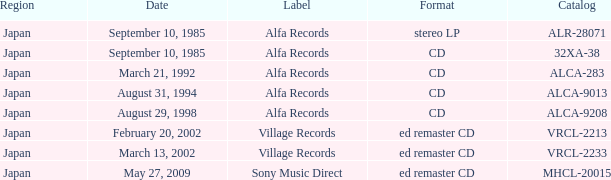Which Label was cataloged as alca-9013? Alfa Records. Parse the full table. {'header': ['Region', 'Date', 'Label', 'Format', 'Catalog'], 'rows': [['Japan', 'September 10, 1985', 'Alfa Records', 'stereo LP', 'ALR-28071'], ['Japan', 'September 10, 1985', 'Alfa Records', 'CD', '32XA-38'], ['Japan', 'March 21, 1992', 'Alfa Records', 'CD', 'ALCA-283'], ['Japan', 'August 31, 1994', 'Alfa Records', 'CD', 'ALCA-9013'], ['Japan', 'August 29, 1998', 'Alfa Records', 'CD', 'ALCA-9208'], ['Japan', 'February 20, 2002', 'Village Records', 'ed remaster CD', 'VRCL-2213'], ['Japan', 'March 13, 2002', 'Village Records', 'ed remaster CD', 'VRCL-2233'], ['Japan', 'May 27, 2009', 'Sony Music Direct', 'ed remaster CD', 'MHCL-20015']]} 